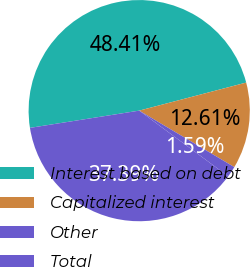Convert chart to OTSL. <chart><loc_0><loc_0><loc_500><loc_500><pie_chart><fcel>Interest based on debt<fcel>Capitalized interest<fcel>Other<fcel>Total<nl><fcel>48.41%<fcel>12.61%<fcel>1.59%<fcel>37.39%<nl></chart> 